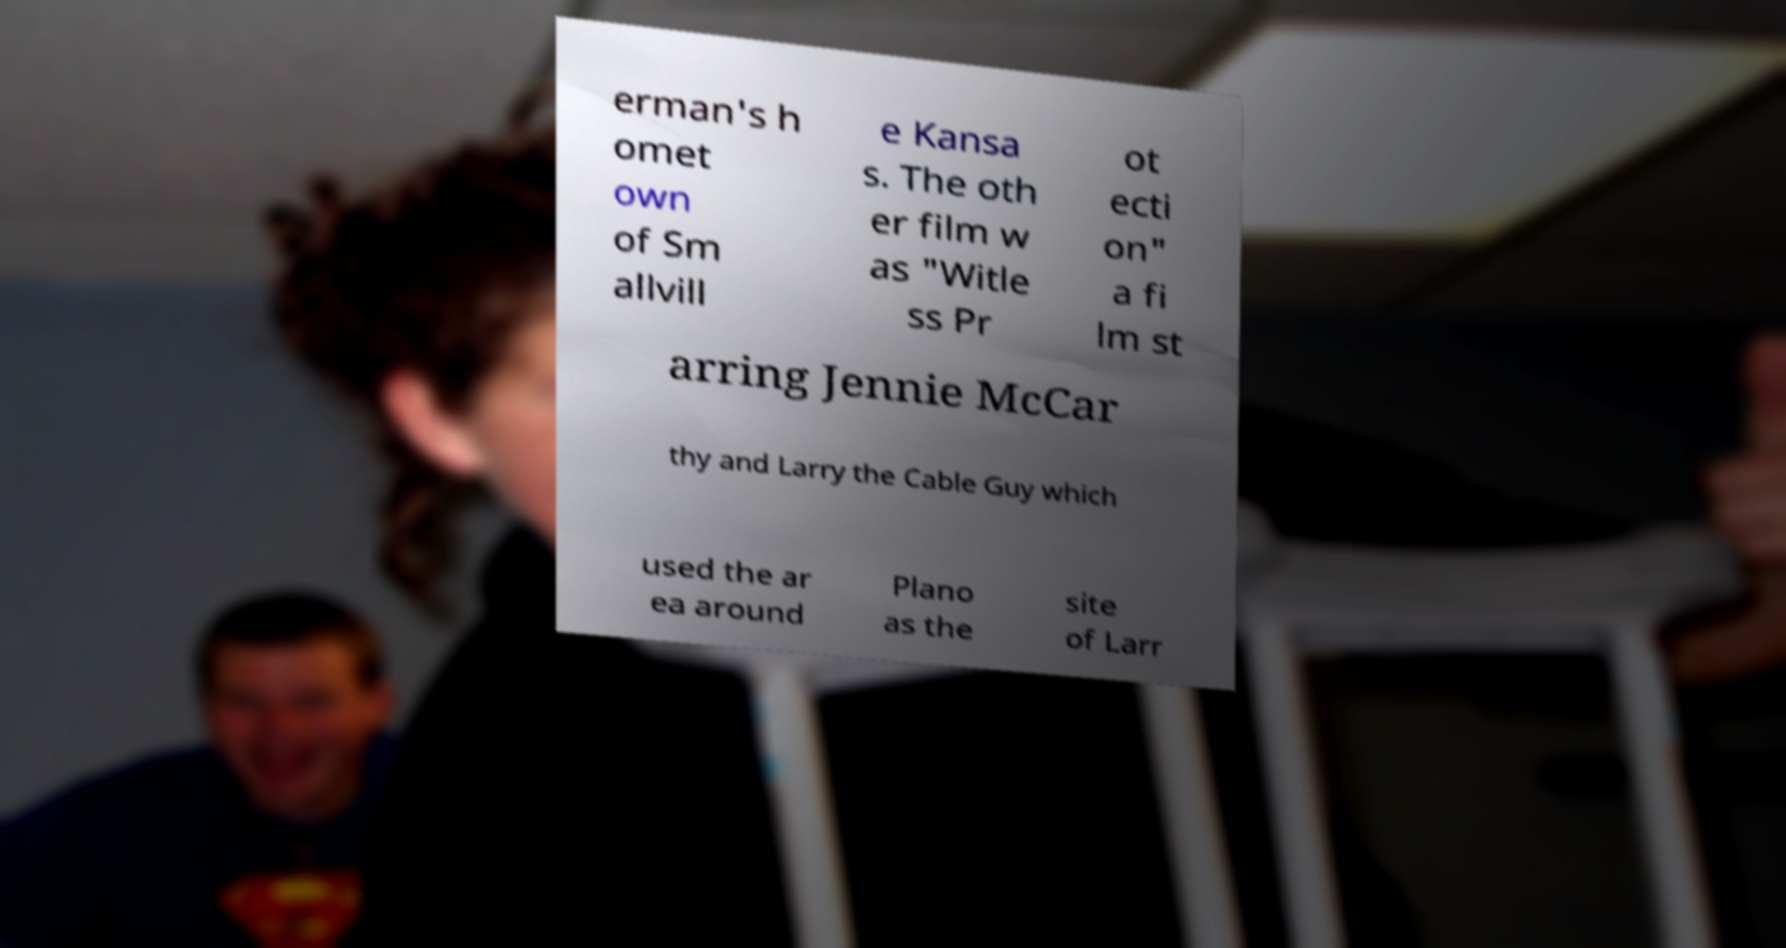Please read and relay the text visible in this image. What does it say? erman's h omet own of Sm allvill e Kansa s. The oth er film w as "Witle ss Pr ot ecti on" a fi lm st arring Jennie McCar thy and Larry the Cable Guy which used the ar ea around Plano as the site of Larr 